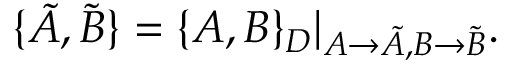<formula> <loc_0><loc_0><loc_500><loc_500>\{ \tilde { A } , \tilde { B } \} = \{ A , B \} _ { D } | _ { A \rightarrow \tilde { A } , B \rightarrow \tilde { B } } .</formula> 